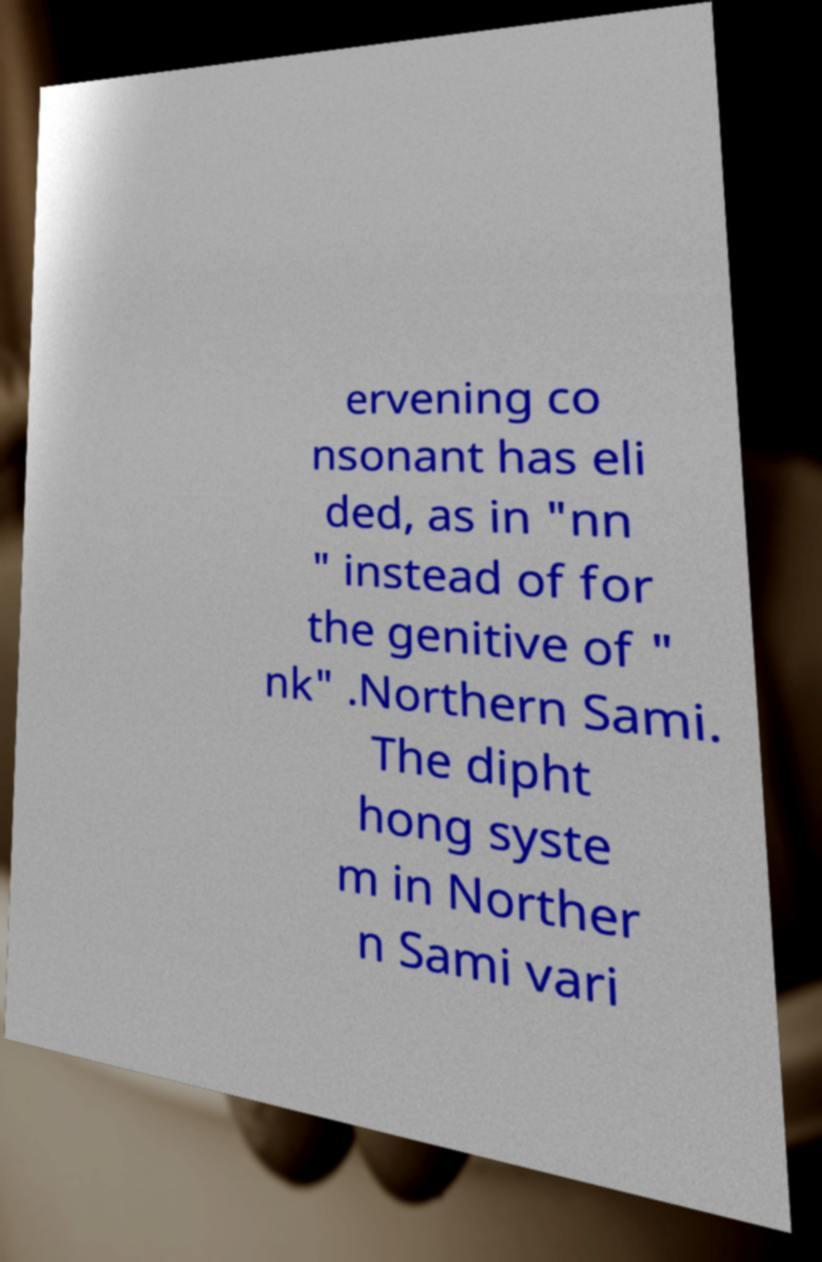Can you read and provide the text displayed in the image?This photo seems to have some interesting text. Can you extract and type it out for me? ervening co nsonant has eli ded, as in "nn " instead of for the genitive of " nk" .Northern Sami. The dipht hong syste m in Norther n Sami vari 